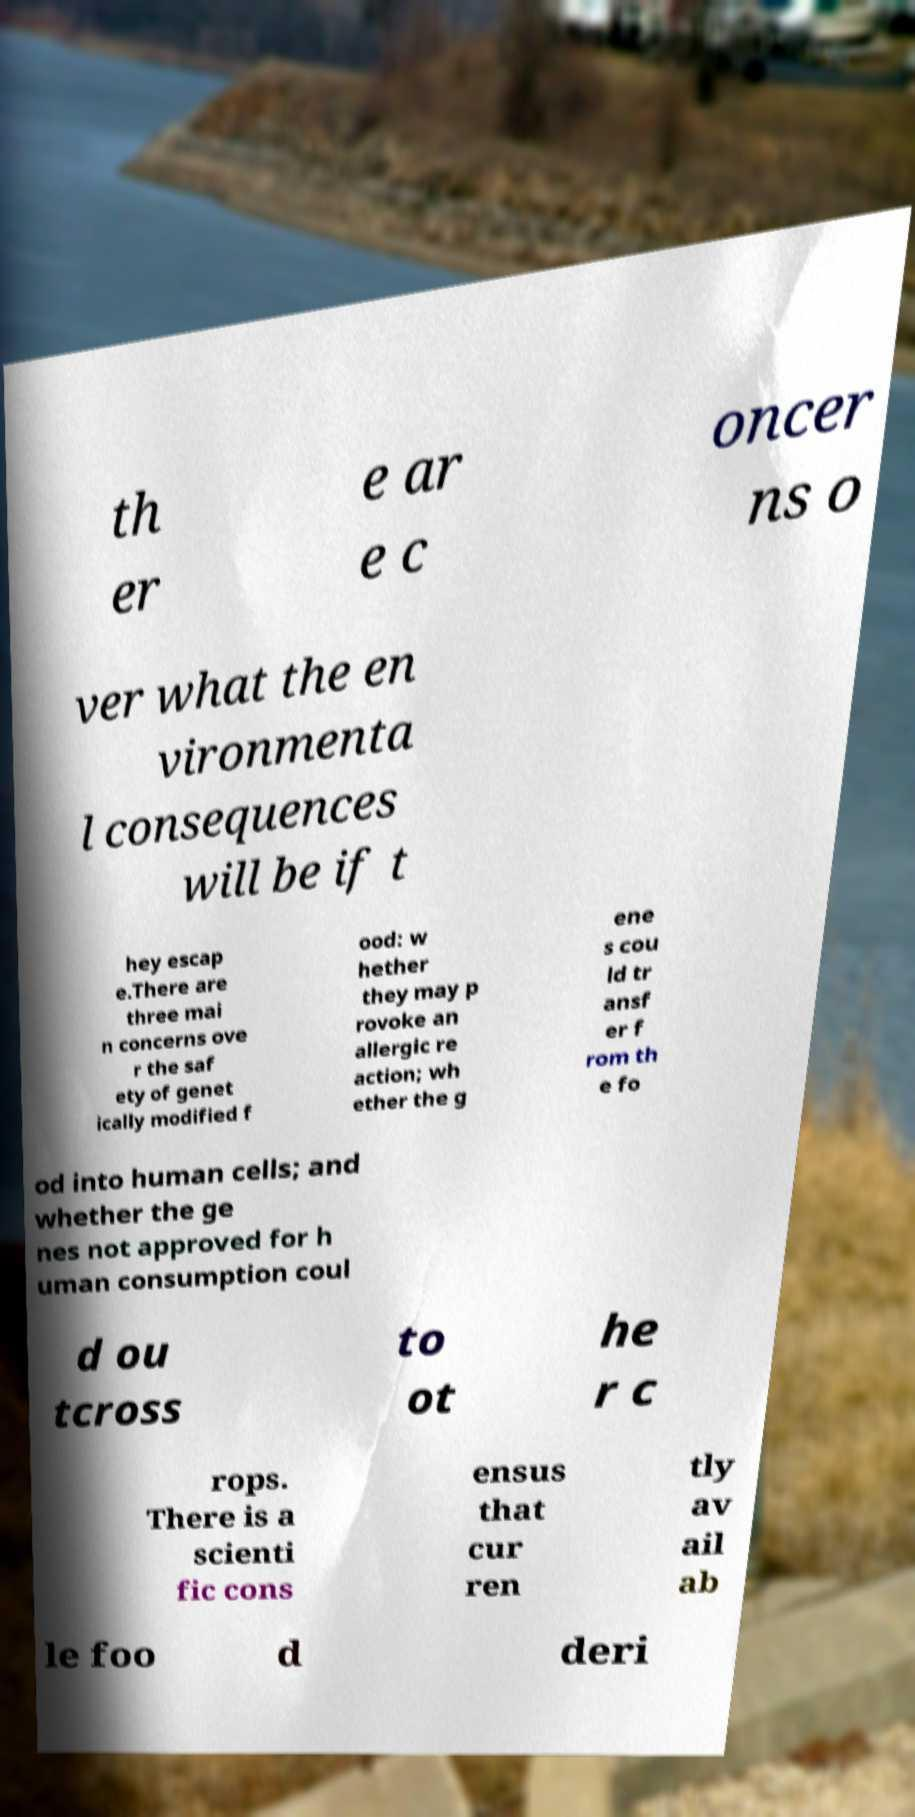I need the written content from this picture converted into text. Can you do that? th er e ar e c oncer ns o ver what the en vironmenta l consequences will be if t hey escap e.There are three mai n concerns ove r the saf ety of genet ically modified f ood: w hether they may p rovoke an allergic re action; wh ether the g ene s cou ld tr ansf er f rom th e fo od into human cells; and whether the ge nes not approved for h uman consumption coul d ou tcross to ot he r c rops. There is a scienti fic cons ensus that cur ren tly av ail ab le foo d deri 